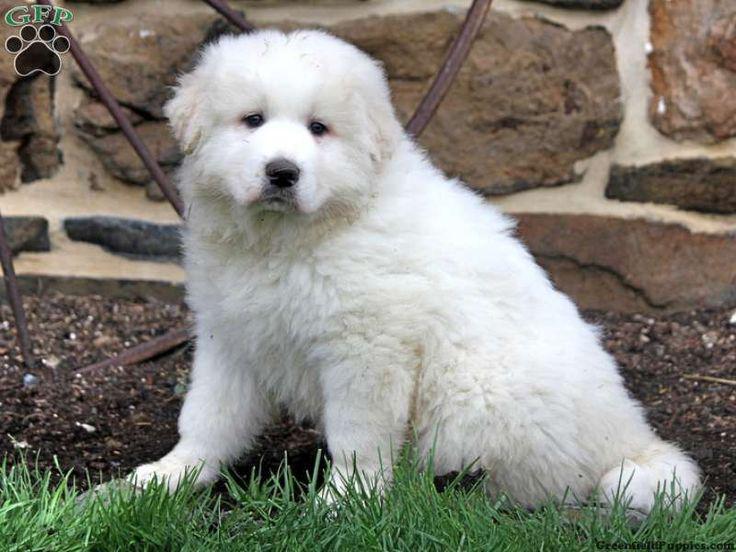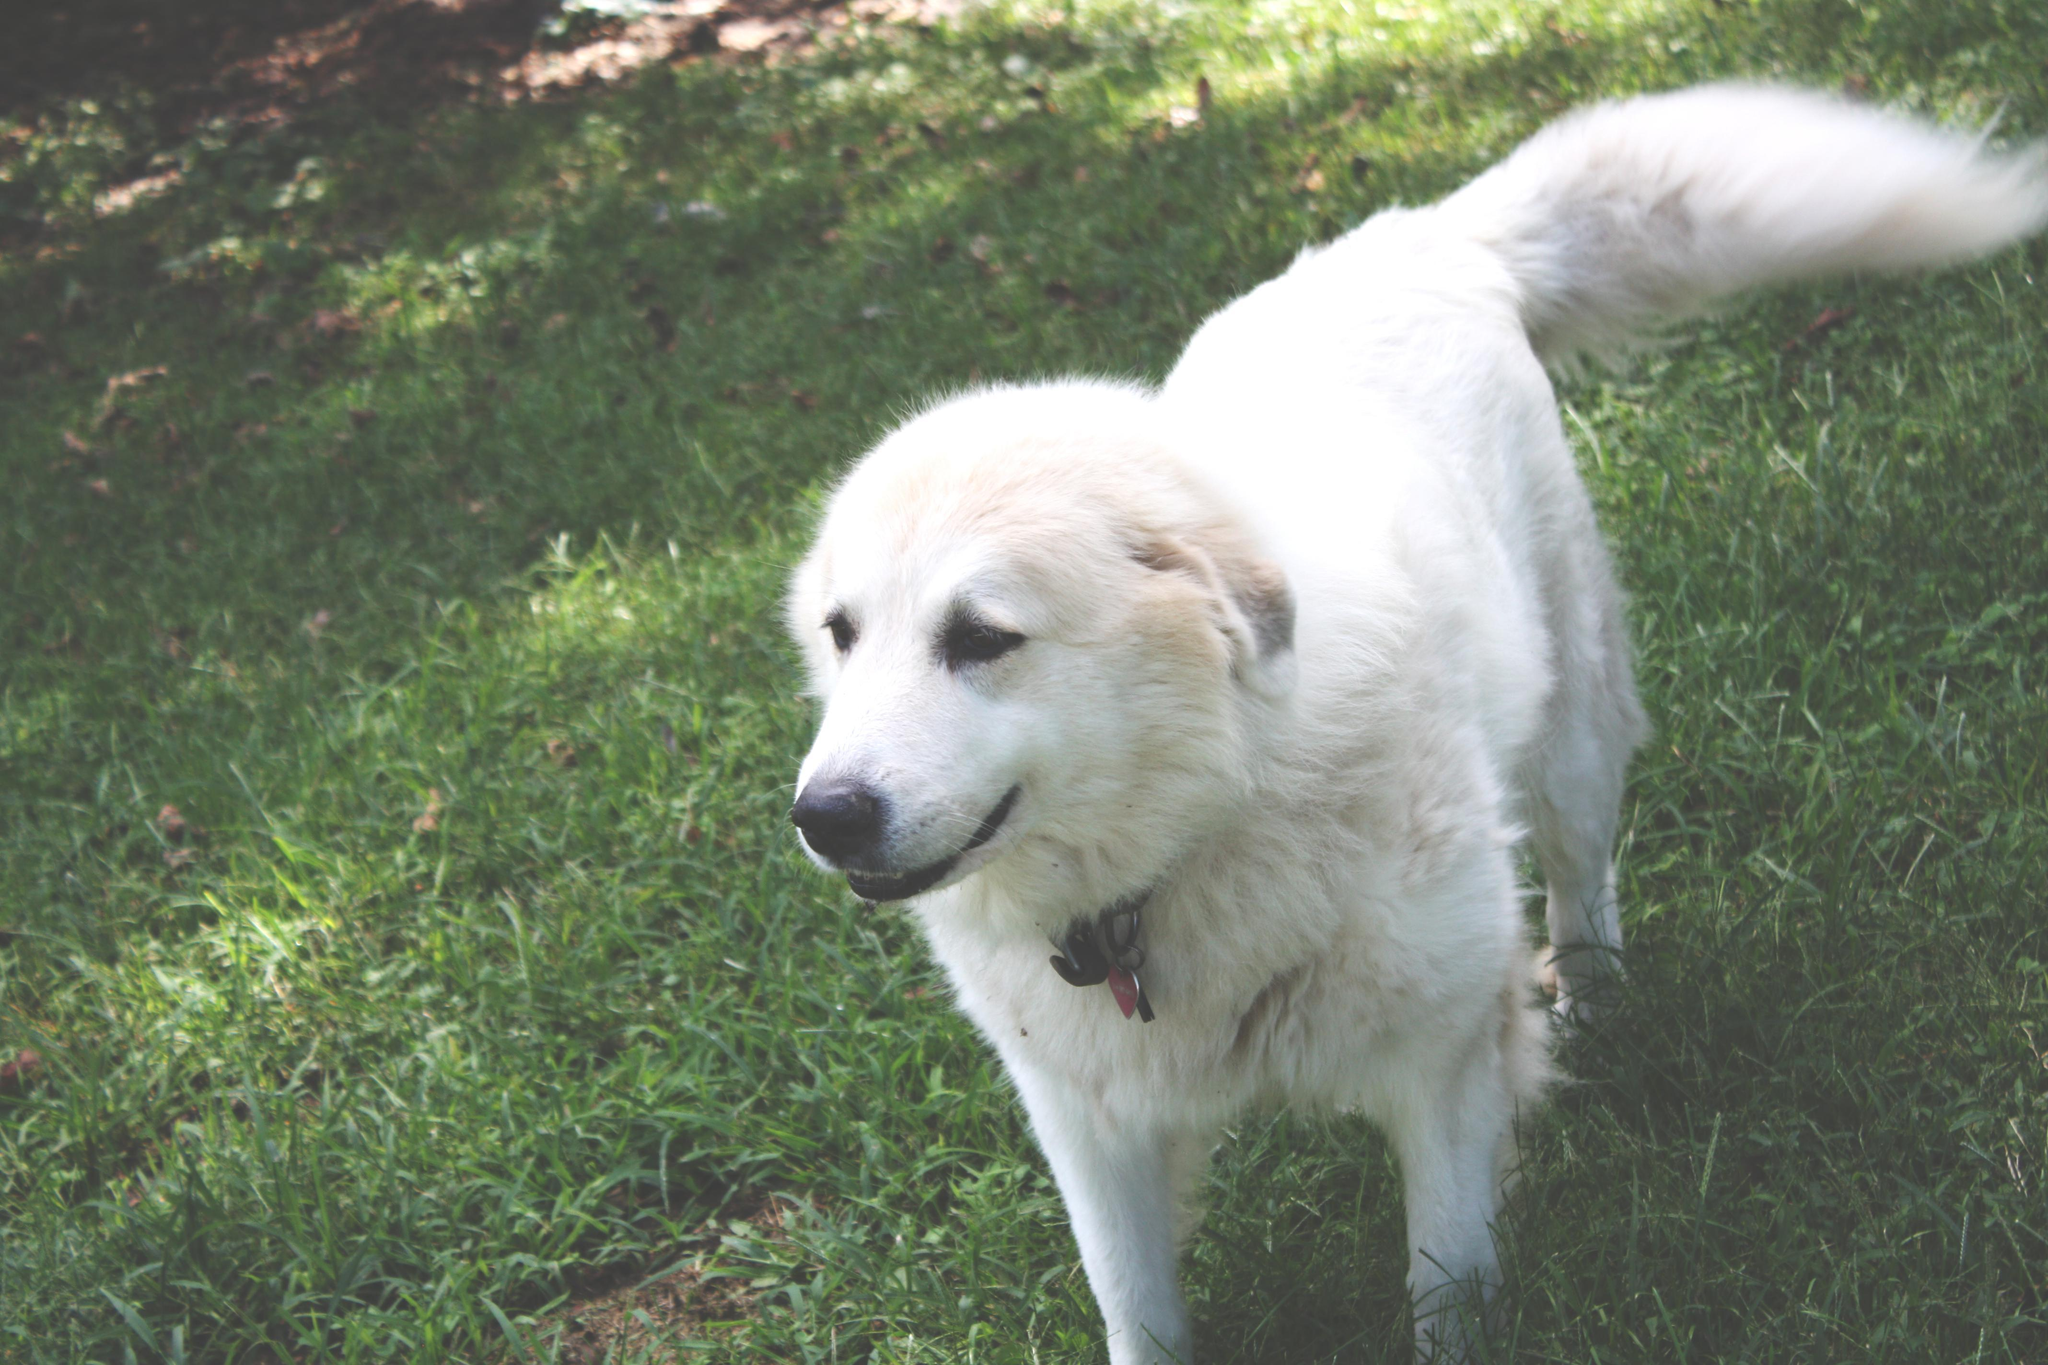The first image is the image on the left, the second image is the image on the right. Evaluate the accuracy of this statement regarding the images: "A single white dog is laying on the grass in the image on the right.". Is it true? Answer yes or no. No. The first image is the image on the left, the second image is the image on the right. Examine the images to the left and right. Is the description "One image shows an adult white dog standing on all fours in a grassy area." accurate? Answer yes or no. Yes. 